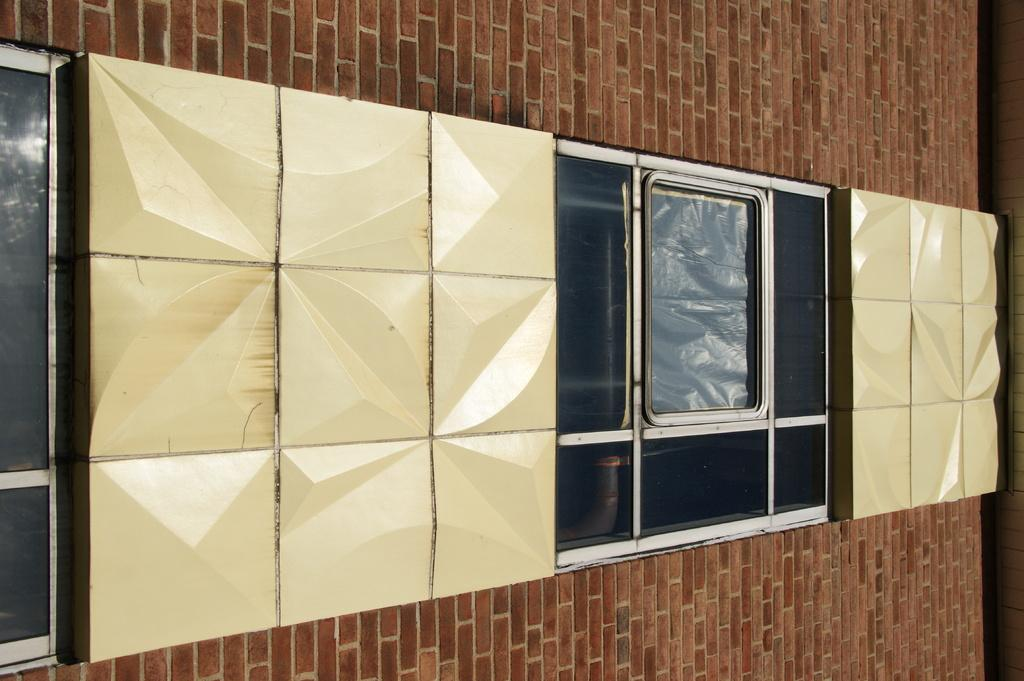What objects can be seen in the image? There are files in the image. What architectural features are visible in the image? There are windows and a wall in the image. What type of voice can be heard coming from the files in the image? There is no voice present in the image, as files are inanimate objects and cannot produce sound. 